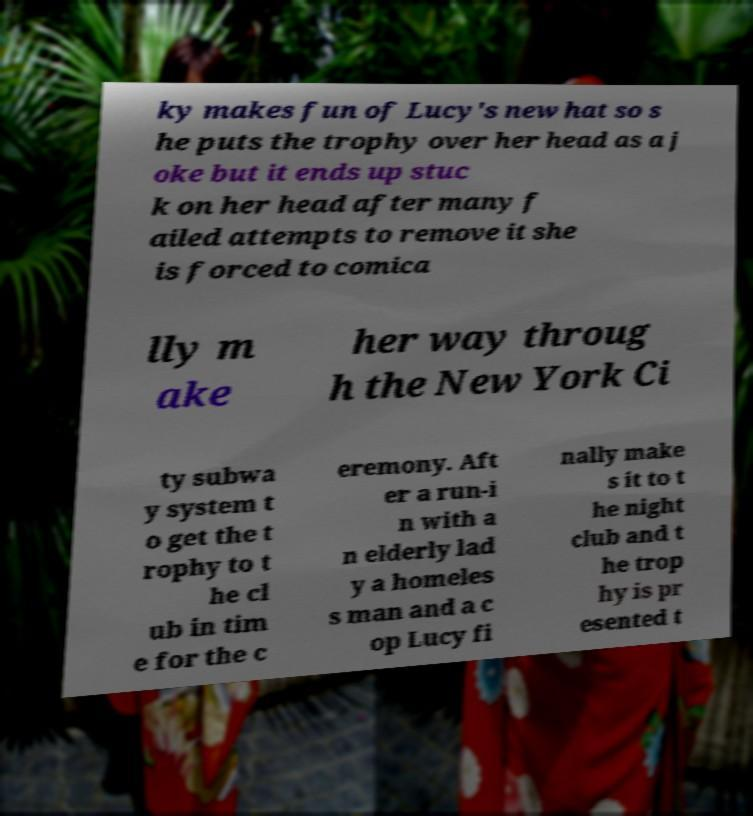I need the written content from this picture converted into text. Can you do that? ky makes fun of Lucy's new hat so s he puts the trophy over her head as a j oke but it ends up stuc k on her head after many f ailed attempts to remove it she is forced to comica lly m ake her way throug h the New York Ci ty subwa y system t o get the t rophy to t he cl ub in tim e for the c eremony. Aft er a run-i n with a n elderly lad y a homeles s man and a c op Lucy fi nally make s it to t he night club and t he trop hy is pr esented t 